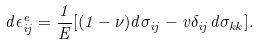<formula> <loc_0><loc_0><loc_500><loc_500>d \epsilon ^ { e } _ { i j } = \frac { 1 } { E } [ ( 1 - \nu ) d \sigma _ { i j } - v \delta _ { i j } d \sigma _ { k k } ] .</formula> 